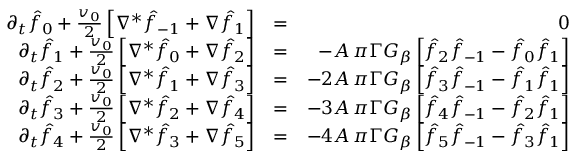Convert formula to latex. <formula><loc_0><loc_0><loc_500><loc_500>\begin{array} { r l r } { \partial _ { t } \hat { f } _ { 0 } + { \frac { v _ { 0 } } { 2 } } \left [ \nabla ^ { * } \hat { f } _ { - 1 } + \nabla \hat { f } _ { 1 } \right ] } & { = } & { 0 } \\ { \partial _ { t } \hat { f } _ { 1 } + { \frac { v _ { 0 } } { 2 } } \left [ \nabla ^ { * } \hat { f } _ { 0 } + \nabla \hat { f } _ { 2 } \right ] } & { = } & { - A \, \pi \Gamma G _ { \beta } \left [ \hat { f } _ { 2 } \hat { f } _ { - 1 } - \hat { f } _ { 0 } \hat { f } _ { 1 } \right ] } \\ { \partial _ { t } \hat { f } _ { 2 } + { \frac { v _ { 0 } } { 2 } } \left [ \nabla ^ { * } \hat { f } _ { 1 } + \nabla \hat { f } _ { 3 } \right ] } & { = } & { - 2 A \, \pi \Gamma G _ { \beta } \left [ \hat { f } _ { 3 } \hat { f } _ { - 1 } - \hat { f } _ { 1 } \hat { f } _ { 1 } \right ] } \\ { \partial _ { t } \hat { f } _ { 3 } + { \frac { v _ { 0 } } { 2 } } \left [ \nabla ^ { * } \hat { f } _ { 2 } + \nabla \hat { f } _ { 4 } \right ] } & { = } & { - 3 A \, \pi \Gamma G _ { \beta } \left [ \hat { f } _ { 4 } \hat { f } _ { - 1 } - \hat { f } _ { 2 } \hat { f } _ { 1 } \right ] } \\ { \partial _ { t } \hat { f } _ { 4 } + { \frac { v _ { 0 } } { 2 } } \left [ \nabla ^ { * } \hat { f } _ { 3 } + \nabla \hat { f } _ { 5 } \right ] } & { = } & { - 4 A \, \pi \Gamma G _ { \beta } \left [ \hat { f } _ { 5 } \hat { f } _ { - 1 } - \hat { f } _ { 3 } \hat { f } _ { 1 } \right ] } \end{array}</formula> 